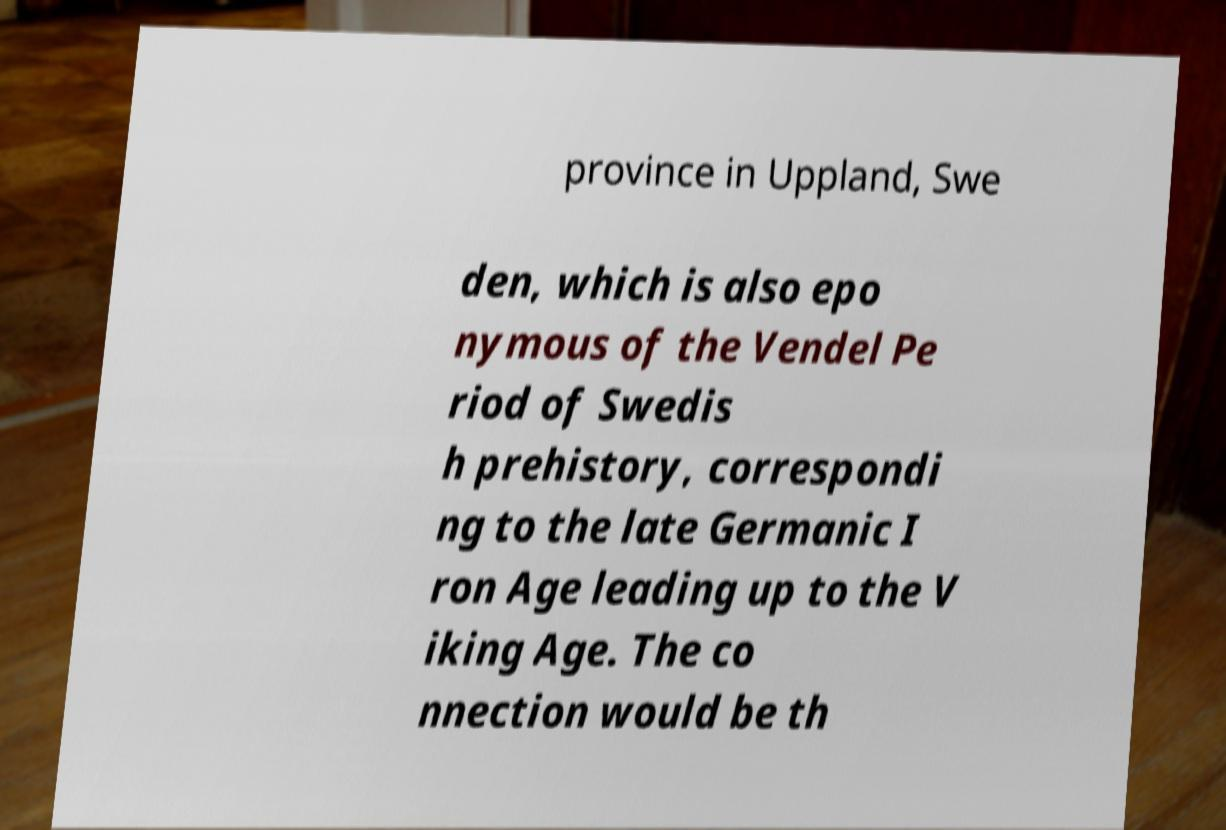Could you assist in decoding the text presented in this image and type it out clearly? province in Uppland, Swe den, which is also epo nymous of the Vendel Pe riod of Swedis h prehistory, correspondi ng to the late Germanic I ron Age leading up to the V iking Age. The co nnection would be th 